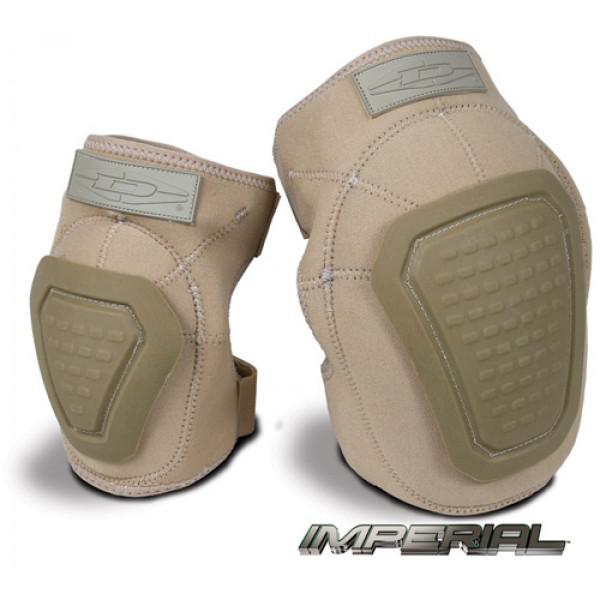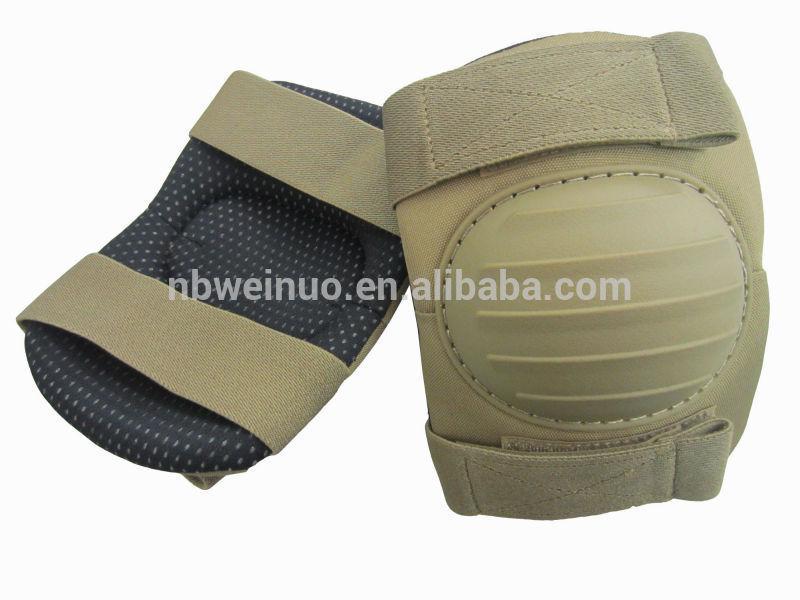The first image is the image on the left, the second image is the image on the right. Evaluate the accuracy of this statement regarding the images: "There are camp patterned knee pads". Is it true? Answer yes or no. No. The first image is the image on the left, the second image is the image on the right. Examine the images to the left and right. Is the description "At least one image shows a pair of kneepads with a camo pattern." accurate? Answer yes or no. No. 